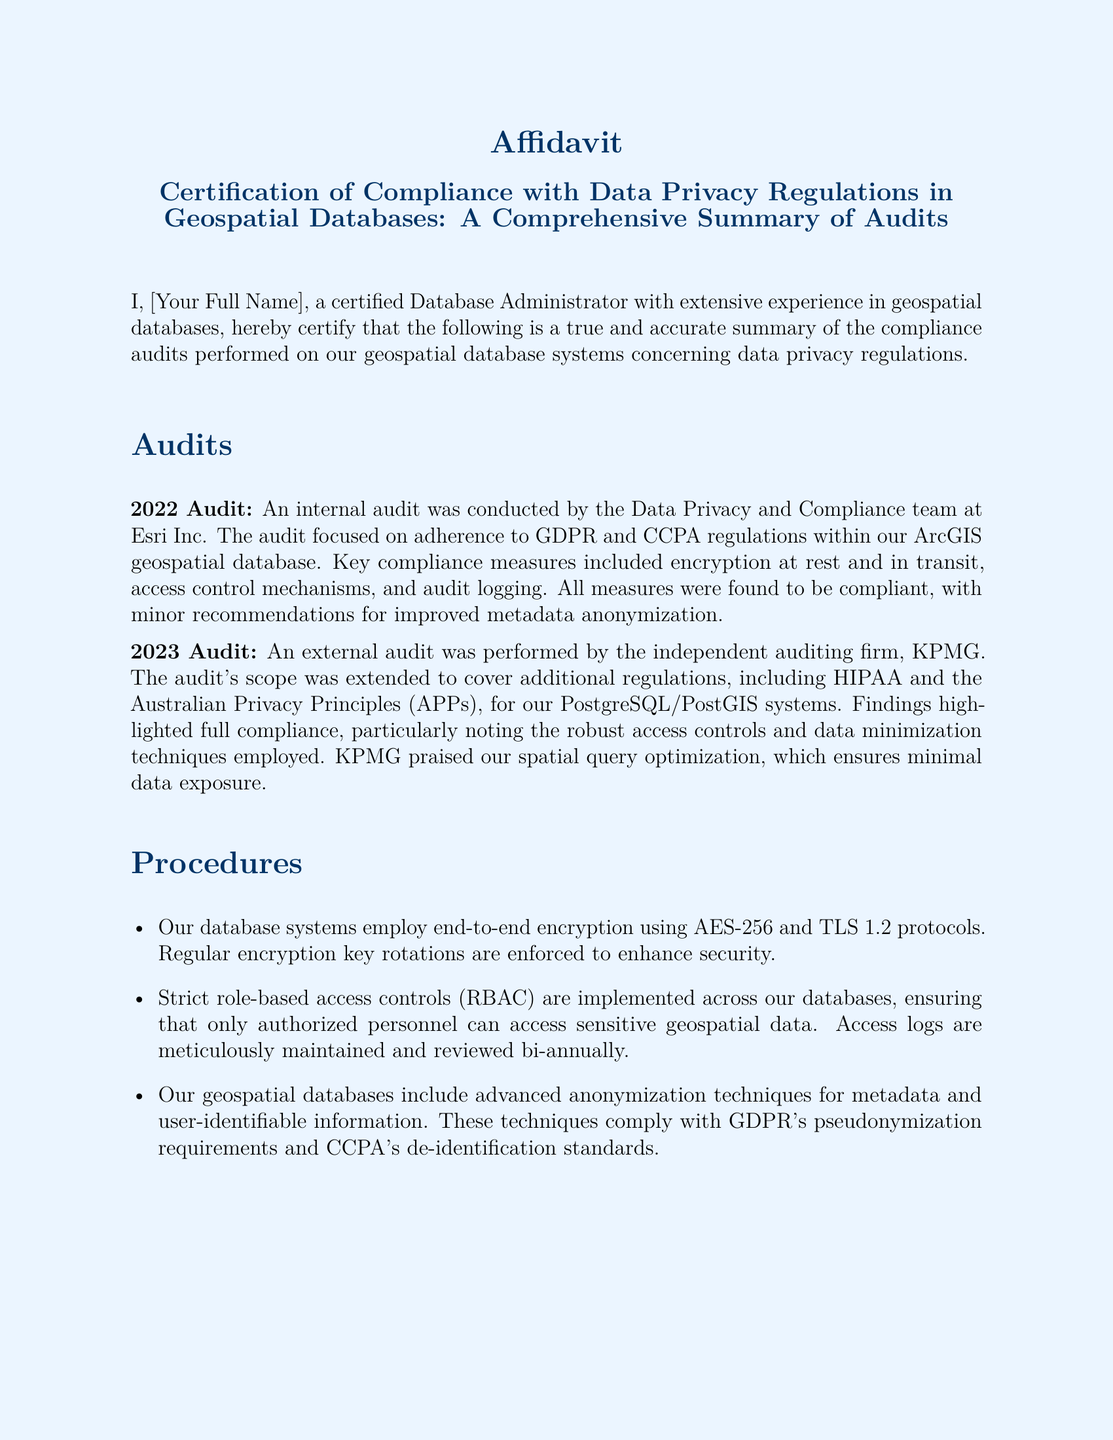What is the full name of the certifying Database Administrator? The document mentions a placeholder for the full name, which is indicated as [Your Full Name].
Answer: [Your Full Name] What company conducted the 2022 audit? The document states that the internal audit was conducted by the Data Privacy and Compliance team at Esri Inc.
Answer: Esri Inc What regulations were primarily focused on during the 2023 audit? The audit's scope included GDPR, CCPA, HIPAA, and the Australian Privacy Principles (APPs).
Answer: GDPR, CCPA, HIPAA, APPs What encryption protocol is used for database security? The document details that end-to-end encryption is implemented using AES-256 and TLS 1.2 protocols.
Answer: AES-256 and TLS 1.2 How often are access logs reviewed? The procedures indicate that access logs are maintained and reviewed bi-annually.
Answer: Bi-annually What was one key recommendation from the 2022 audit? The document states a minor recommendation for improved metadata anonymization was made during the audit.
Answer: Metadata anonymization Who performed the 2023 audit? The external audit was conducted by the independent auditing firm, KPMG.
Answer: KPMG What aspect of the database was praised by KPMG? The findings highlighted appreciation for the robust access controls and data minimization techniques employed.
Answer: Robust access controls and data minimization techniques What kind of compliance measures were found in the audits? Compliance measures included encryption, access control mechanisms, and audit logging as stated in the audits summary.
Answer: Encryption, access control, and audit logging 